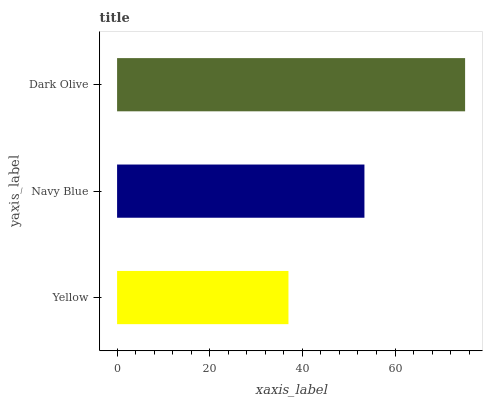Is Yellow the minimum?
Answer yes or no. Yes. Is Dark Olive the maximum?
Answer yes or no. Yes. Is Navy Blue the minimum?
Answer yes or no. No. Is Navy Blue the maximum?
Answer yes or no. No. Is Navy Blue greater than Yellow?
Answer yes or no. Yes. Is Yellow less than Navy Blue?
Answer yes or no. Yes. Is Yellow greater than Navy Blue?
Answer yes or no. No. Is Navy Blue less than Yellow?
Answer yes or no. No. Is Navy Blue the high median?
Answer yes or no. Yes. Is Navy Blue the low median?
Answer yes or no. Yes. Is Yellow the high median?
Answer yes or no. No. Is Yellow the low median?
Answer yes or no. No. 